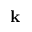<formula> <loc_0><loc_0><loc_500><loc_500>k</formula> 